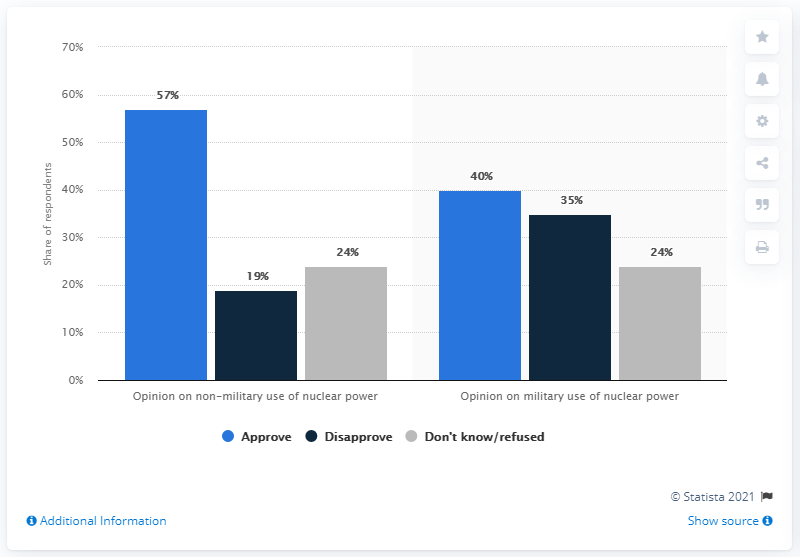Outline some significant characteristics in this image. In 2012, the average approval rate for Iranian adults regarding the use of nuclear power for both military and non-military purposes was 48.5%. In 2012, the highest approval rate of Iranian adults for nuclear power capabilities, both military and non-military, was 57%. 